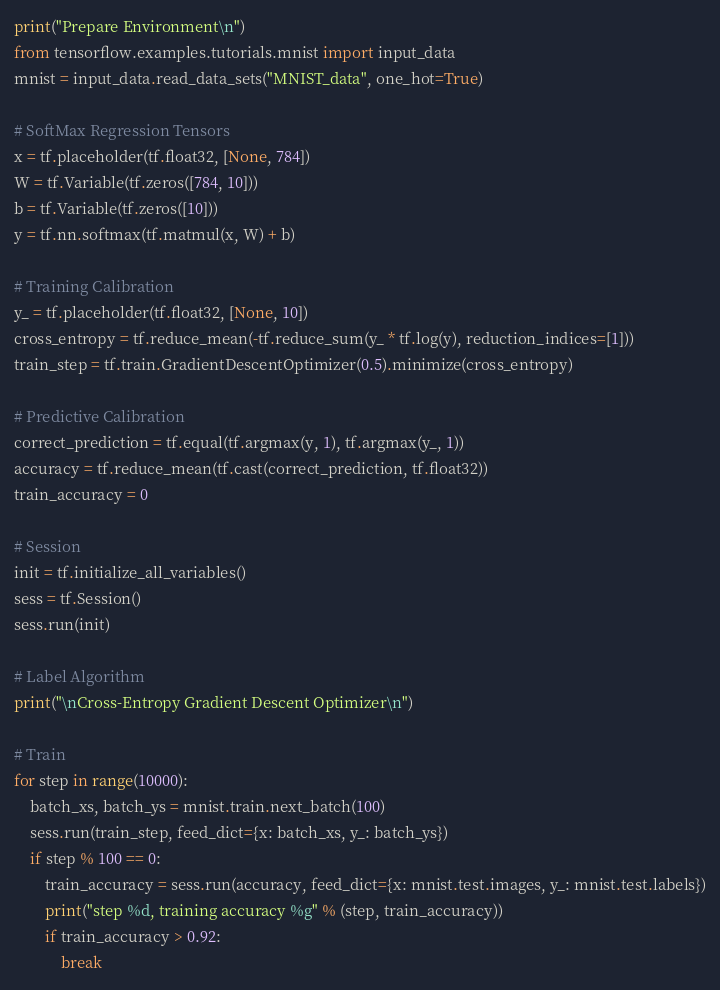<code> <loc_0><loc_0><loc_500><loc_500><_Python_>print("Prepare Environment\n")
from tensorflow.examples.tutorials.mnist import input_data
mnist = input_data.read_data_sets("MNIST_data", one_hot=True)

# SoftMax Regression Tensors
x = tf.placeholder(tf.float32, [None, 784])
W = tf.Variable(tf.zeros([784, 10]))
b = tf.Variable(tf.zeros([10]))
y = tf.nn.softmax(tf.matmul(x, W) + b)

# Training Calibration
y_ = tf.placeholder(tf.float32, [None, 10])
cross_entropy = tf.reduce_mean(-tf.reduce_sum(y_ * tf.log(y), reduction_indices=[1]))
train_step = tf.train.GradientDescentOptimizer(0.5).minimize(cross_entropy)

# Predictive Calibration
correct_prediction = tf.equal(tf.argmax(y, 1), tf.argmax(y_, 1))
accuracy = tf.reduce_mean(tf.cast(correct_prediction, tf.float32))
train_accuracy = 0

# Session
init = tf.initialize_all_variables()
sess = tf.Session()
sess.run(init)

# Label Algorithm
print("\nCross-Entropy Gradient Descent Optimizer\n")

# Train
for step in range(10000):
    batch_xs, batch_ys = mnist.train.next_batch(100)
    sess.run(train_step, feed_dict={x: batch_xs, y_: batch_ys})
    if step % 100 == 0:
        train_accuracy = sess.run(accuracy, feed_dict={x: mnist.test.images, y_: mnist.test.labels})
        print("step %d, training accuracy %g" % (step, train_accuracy))
        if train_accuracy > 0.92:
            break
</code> 